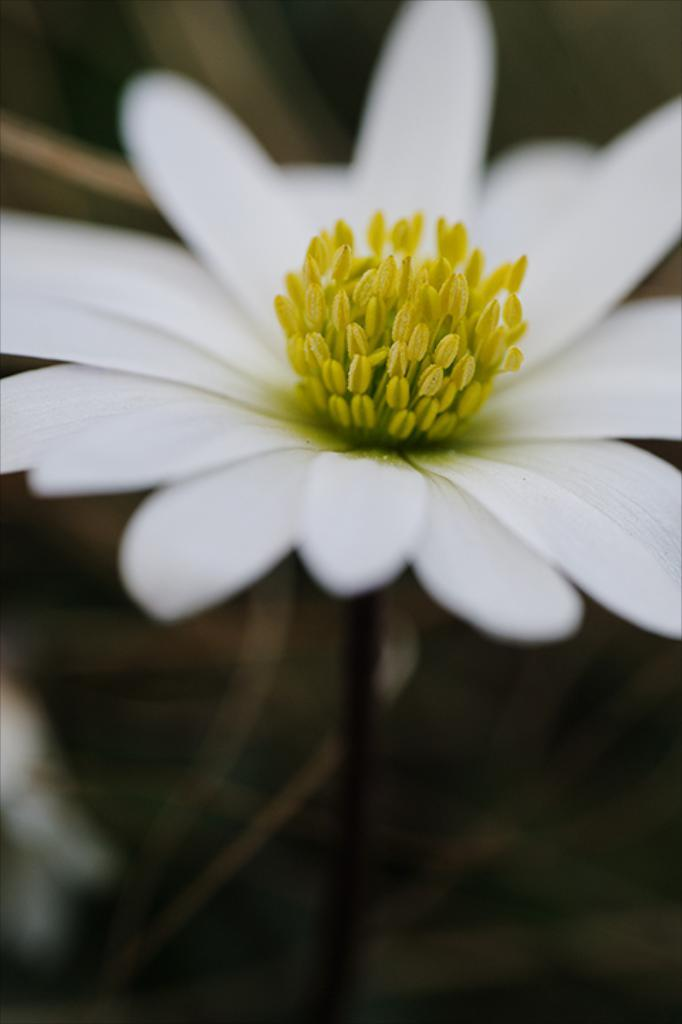What type of flower is in the image? There is a white color flower in the image. Can you describe the background of the image? The background of the image is dark and blurred. What type of wound is visible on the carpenter in the image? There is no carpenter or wound present in the image; it only features a white color flower with a dark and blurred background. 